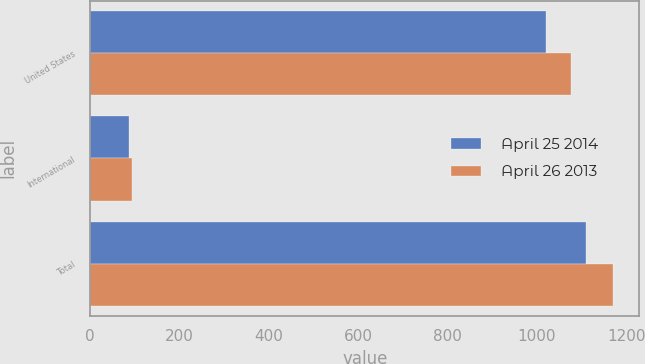Convert chart. <chart><loc_0><loc_0><loc_500><loc_500><stacked_bar_chart><ecel><fcel>United States<fcel>International<fcel>Total<nl><fcel>April 25 2014<fcel>1021.4<fcel>87.4<fcel>1108.8<nl><fcel>April 26 2013<fcel>1076.3<fcel>94.6<fcel>1170.9<nl></chart> 